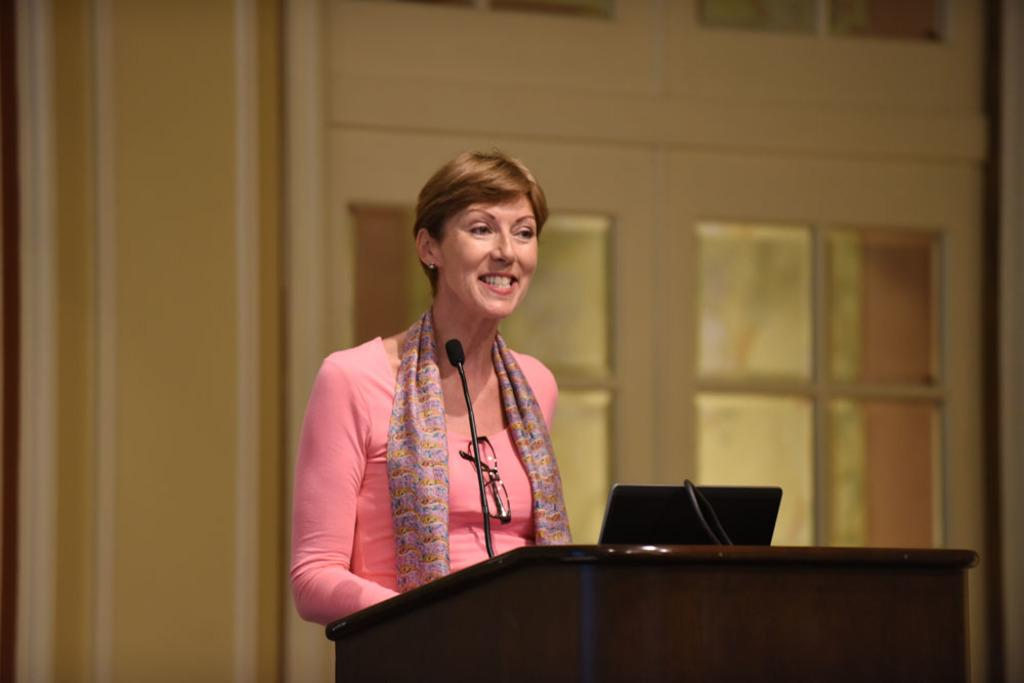Who is the main subject in the image? There is a woman in the image. What is the woman doing in the image? The woman is standing near a podium. What is the woman's facial expression in the image? The woman is smiling in the image. What objects are in front of the woman? There is a microphone and a monitor screen in front of the woman. What can be seen in the background of the image? There is a wall and a door in the background of the image. Why is the goose crying in the image? There is no goose present in the image, and therefore no such activity can be observed. 